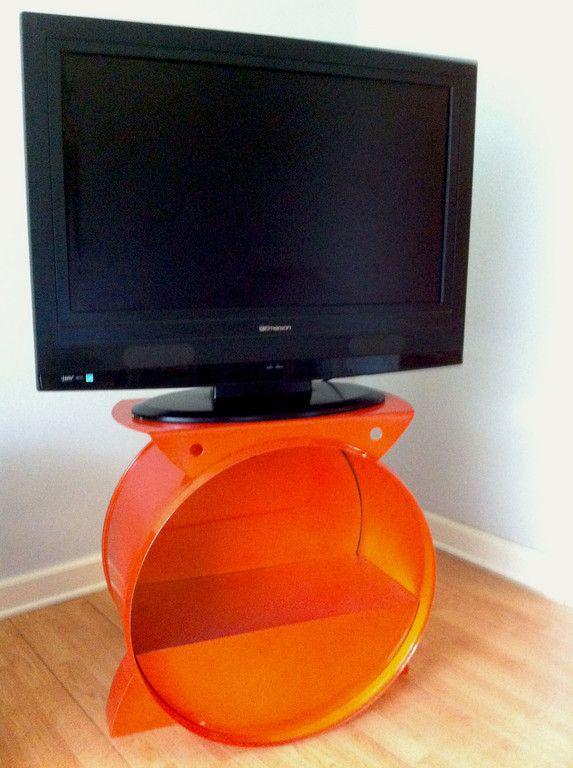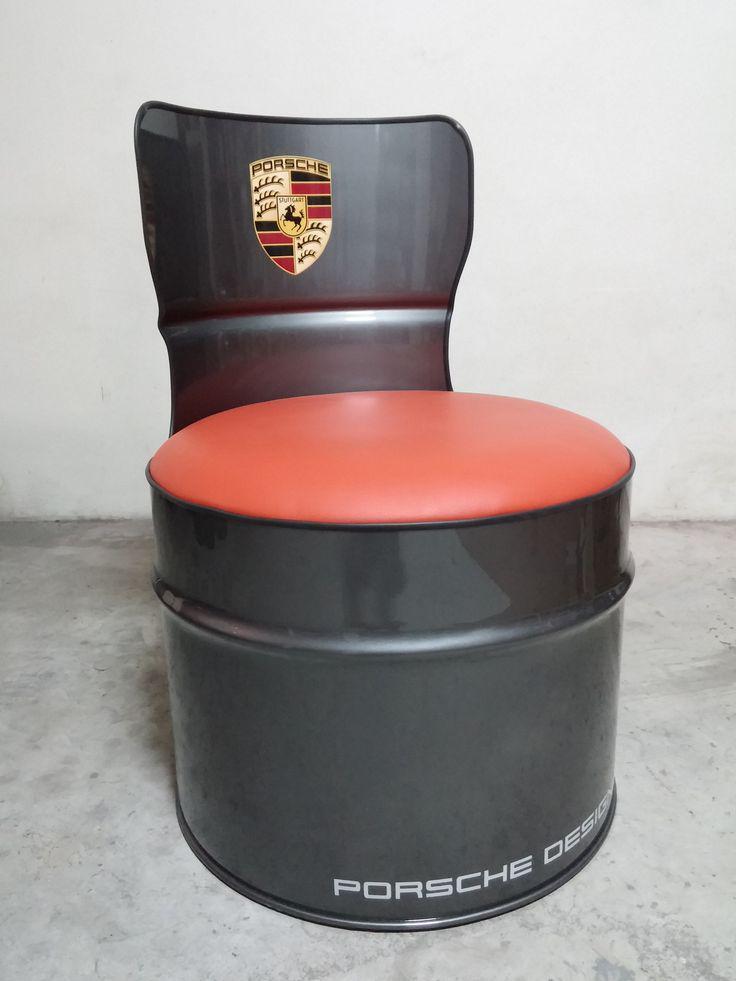The first image is the image on the left, the second image is the image on the right. Evaluate the accuracy of this statement regarding the images: "The combined images contain two red barrels that have been turned into seats, with the barrel on stands on its side.". Is it true? Answer yes or no. No. The first image is the image on the left, the second image is the image on the right. For the images displayed, is the sentence "There are at least three chairs that are cushioned." factually correct? Answer yes or no. No. 